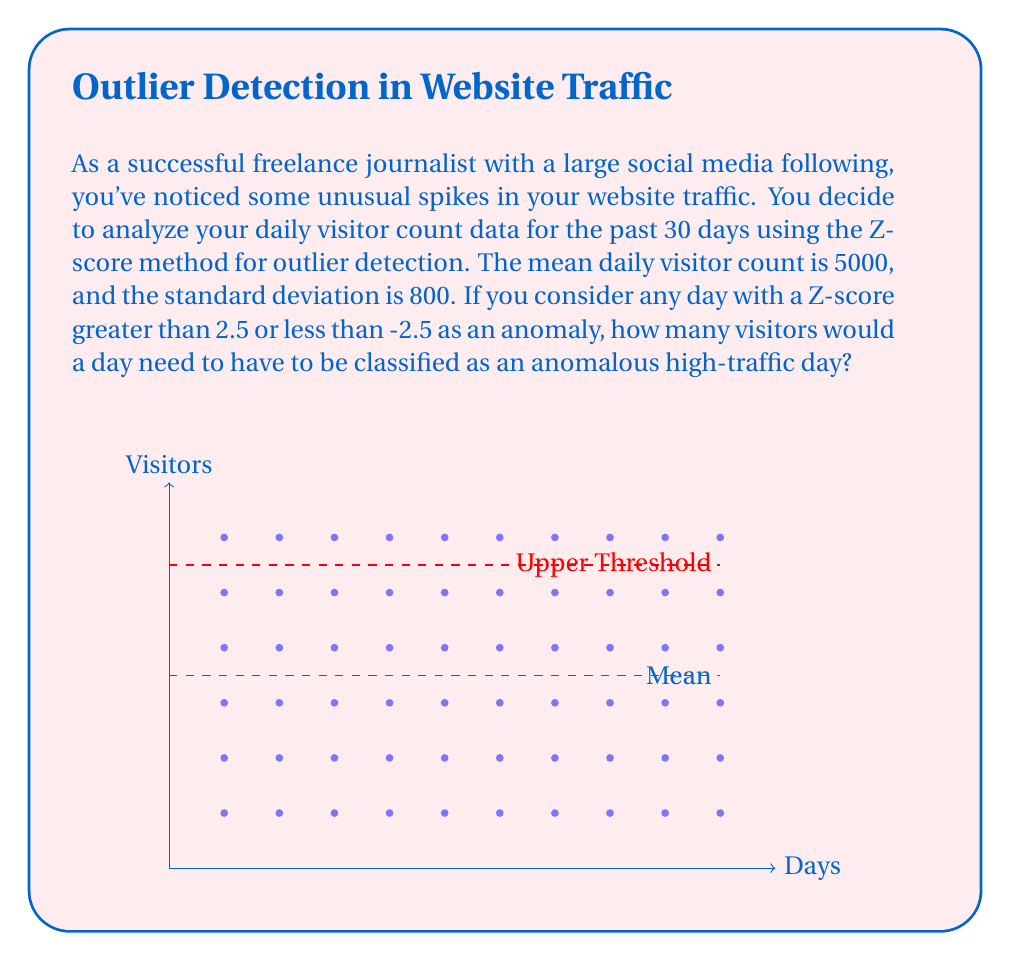Teach me how to tackle this problem. To solve this problem, we'll use the Z-score formula and the given information:

1) The Z-score formula is:

   $$Z = \frac{X - \mu}{\sigma}$$

   Where:
   $X$ is the value we're solving for
   $\mu$ is the mean (5000)
   $\sigma$ is the standard deviation (800)

2) We're told that a Z-score greater than 2.5 is considered an anomaly. So, we'll use 2.5 in our calculation:

   $$2.5 = \frac{X - 5000}{800}$$

3) Now, let's solve for $X$:

   $$2.5 \cdot 800 = X - 5000$$
   $$2000 = X - 5000$$
   $$X = 7000$$

4) Therefore, any day with 7000 or more visitors would be considered an anomalous high-traffic day.

This method allows us to detect unusual spikes in website traffic that are significantly above the normal range, which could indicate viral content, a successful marketing campaign, or other noteworthy events that a journalist might want to investigate or capitalize on.
Answer: 7000 visitors 